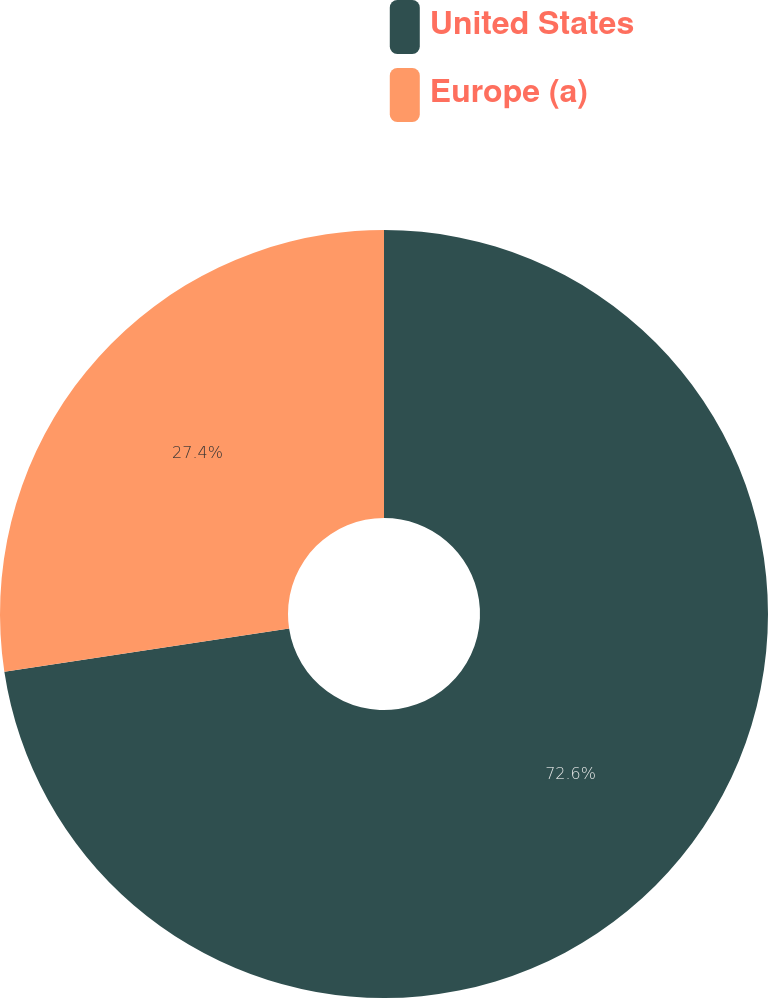Convert chart. <chart><loc_0><loc_0><loc_500><loc_500><pie_chart><fcel>United States<fcel>Europe (a)<nl><fcel>72.6%<fcel>27.4%<nl></chart> 